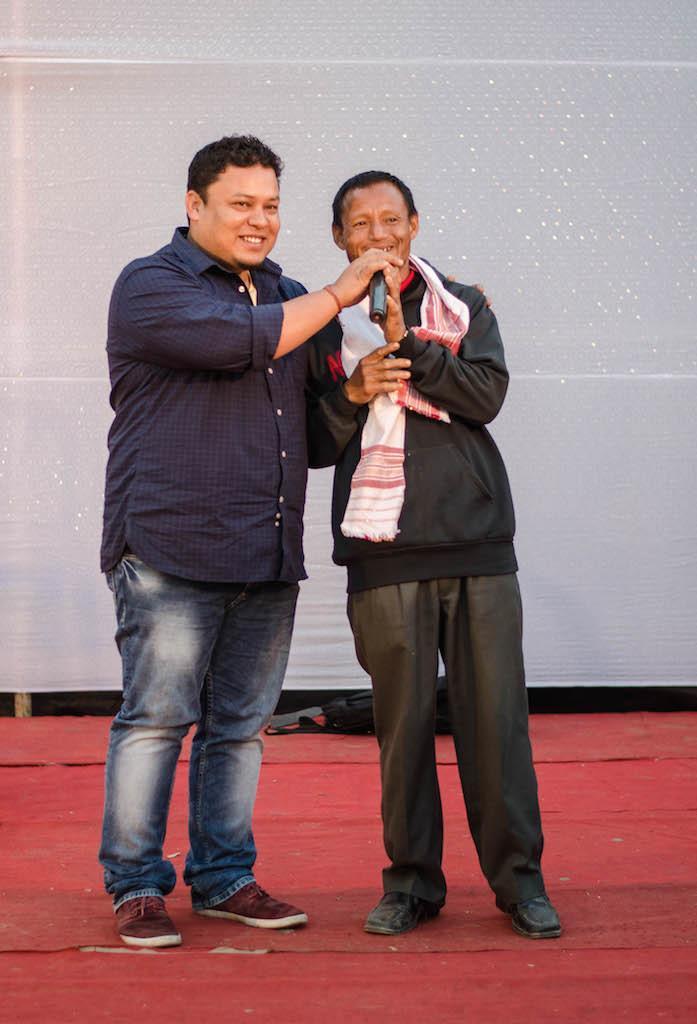Describe this image in one or two sentences. In this image there are two people standing on stage in which one of them is holding microphone and letting the other one speaking in it. 